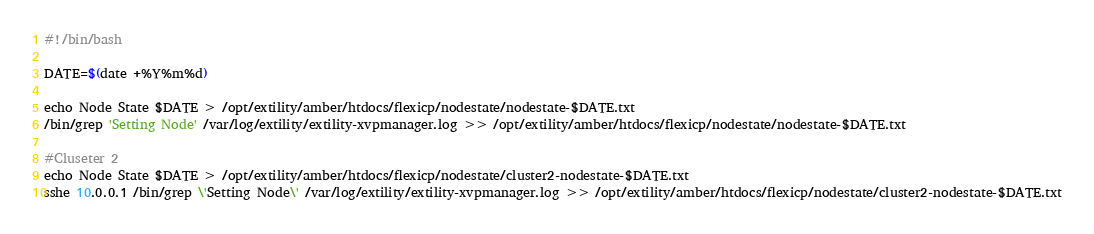<code> <loc_0><loc_0><loc_500><loc_500><_Bash_>#!/bin/bash

DATE=$(date +%Y%m%d) 

echo Node State $DATE > /opt/extility/amber/htdocs/flexicp/nodestate/nodestate-$DATE.txt 
/bin/grep 'Setting Node' /var/log/extility/extility-xvpmanager.log >> /opt/extility/amber/htdocs/flexicp/nodestate/nodestate-$DATE.txt

#Cluseter 2
echo Node State $DATE > /opt/extility/amber/htdocs/flexicp/nodestate/cluster2-nodestate-$DATE.txt
sshe 10.0.0.1 /bin/grep \'Setting Node\' /var/log/extility/extility-xvpmanager.log >> /opt/extility/amber/htdocs/flexicp/nodestate/cluster2-nodestate-$DATE.txt
</code> 